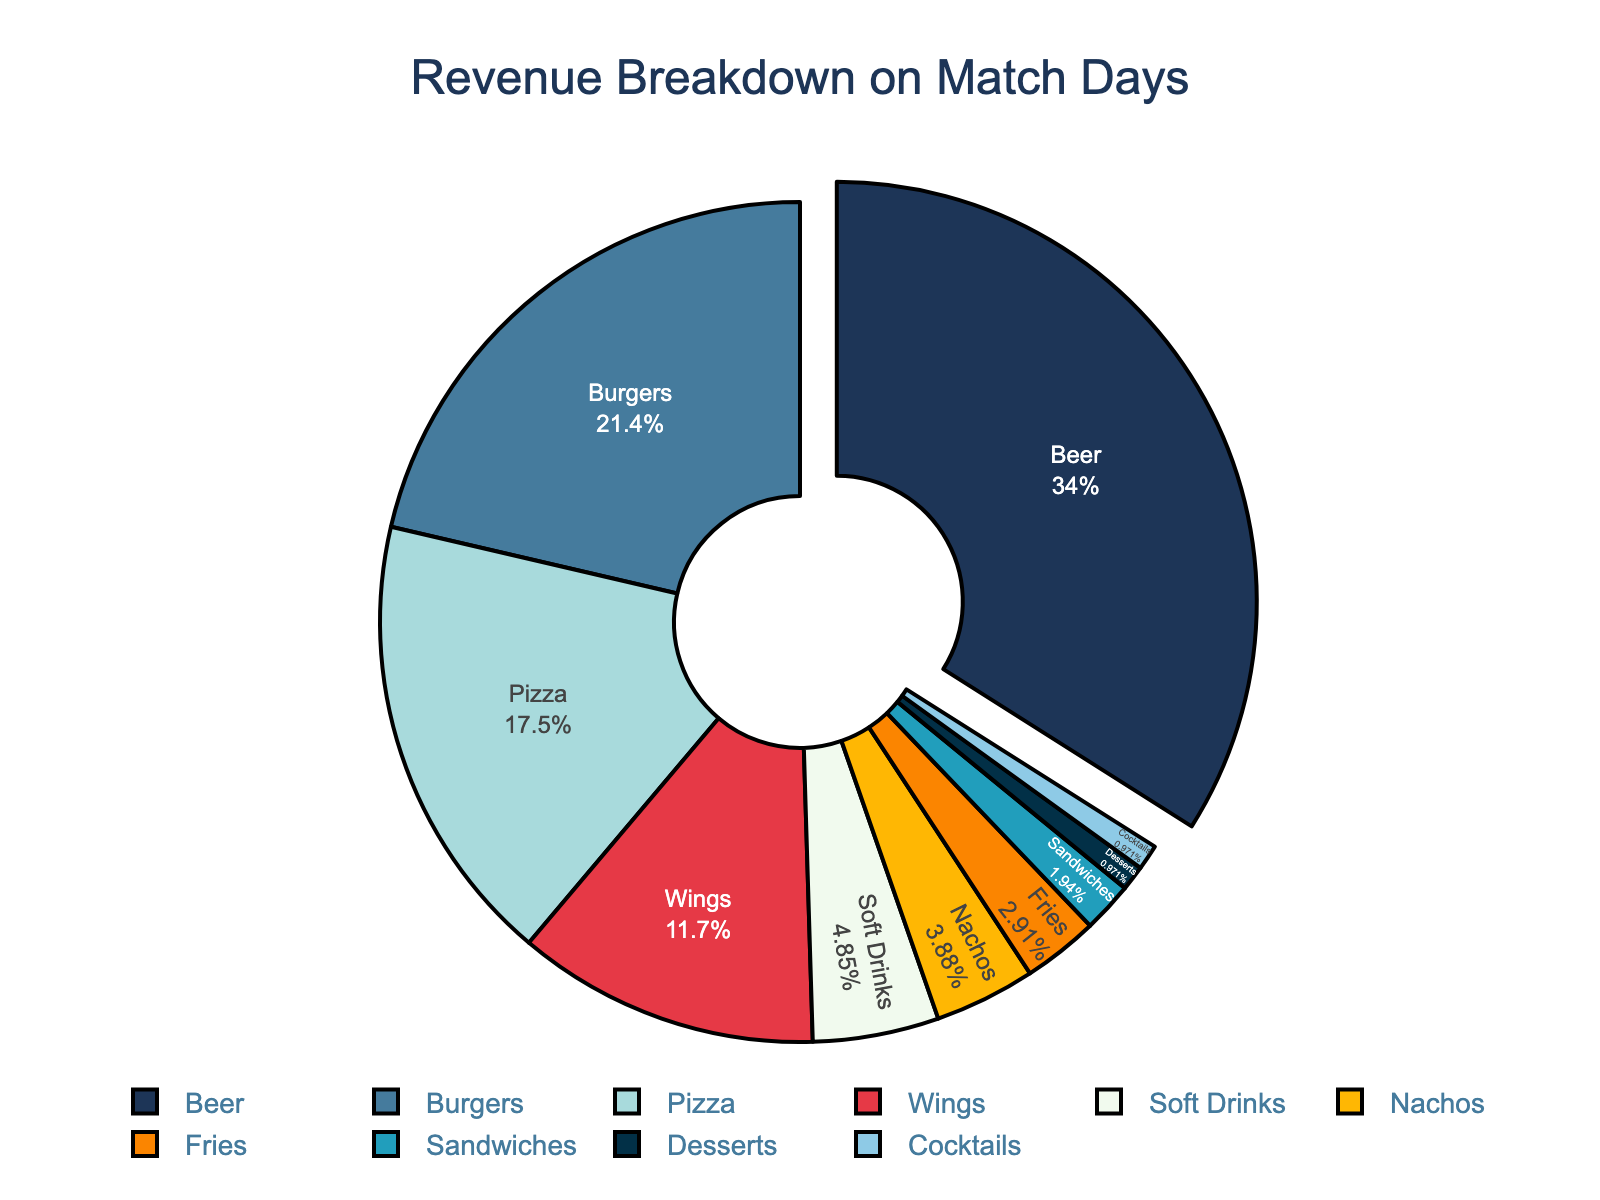what percentage of the revenue comes from beer? The figure shows the percentage of each category directly. Looking at the label for beer, it states the percentage next to it.
Answer: 35% which category generates the least revenue? The figure shows the categories and their corresponding revenue percentages. The category with the smallest slice and percentage represents the least revenue.
Answer: Cocktails how much more revenue does beer generate compared to nachos? From the figure, note the percentages for beer and nachos. Calculate the difference: 35% (beer) - 4% (nachos).
Answer: 31% what is the combined revenue percentage for burgers and pizza? From the figure, note the percentages for both burgers and pizza. Add them together: 22% (burgers) + 18% (pizza).
Answer: 40% which item category is the second most popular? The figure segments categories by percentage of revenue. The second largest slice after beer represents the second most popular category.
Answer: Burgers how does the revenue from wings compare to that from soft drinks? From the figure, observe the percentages for wings and soft drinks and compare them. Wings have a higher percentage than soft drinks: 12% (wings) versus 5% (soft drinks).
Answer: Wings > Soft Drinks what is the difference between revenue percentages of fries and wings? From the figure, note the percentages for fries and wings. Calculate the difference: 12% (wings) - 3% (fries).
Answer: 9% which category nearest in revenue percentage to pizza? From the figure, looking for the category with the percentage closest to pizza (18%). Burgers with 22%, and wings with 12%, are the closest.
Answer: Wings if the total revenue is $1000, how much revenue is generated from beers and fries combined? From the figure, note the percentages for beer and fries. Combine these percentages and apply to $1000: (35% + 3%) * $1000 = 38% * $1000.
Answer: $380 which category shares the same color as wings? By observing the colors used for each category in the figure, determine which segment shares the same color as the wings slice.
Answer: No other category shares the same color as wings 